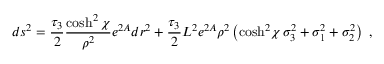<formula> <loc_0><loc_0><loc_500><loc_500>d s ^ { 2 } = { \frac { \tau _ { 3 } } { 2 } } { \frac { \cosh ^ { 2 } \chi } { \rho ^ { 2 } } } e ^ { 2 A } d r ^ { 2 } + { \frac { \tau _ { 3 } } { 2 } } { L ^ { 2 } } { e ^ { 2 A } } \rho ^ { 2 } \left ( { \cosh ^ { 2 } \, \chi } \, \sigma _ { 3 } ^ { 2 } + \sigma _ { 1 } ^ { 2 } + \sigma _ { 2 } ^ { 2 } \right ) \ ,</formula> 